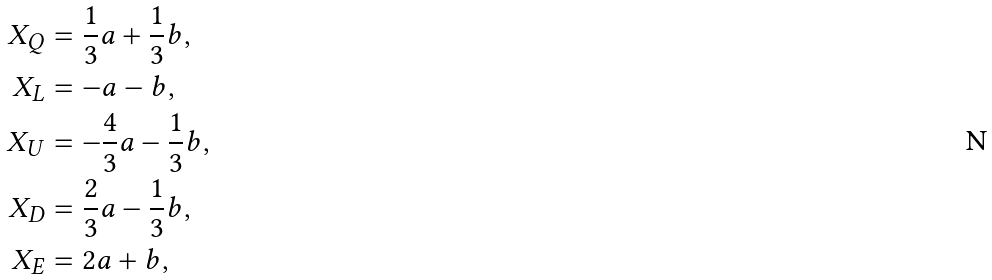Convert formula to latex. <formula><loc_0><loc_0><loc_500><loc_500>X _ { Q } & = \frac { 1 } { 3 } a + \frac { 1 } { 3 } b , \\ X _ { L } & = - a - b , \\ X _ { U } & = - \frac { 4 } { 3 } a - \frac { 1 } { 3 } b , \\ X _ { D } & = \frac { 2 } { 3 } a - \frac { 1 } { 3 } b , \\ X _ { E } & = 2 a + b ,</formula> 